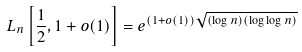Convert formula to latex. <formula><loc_0><loc_0><loc_500><loc_500>L _ { n } \left [ { \frac { 1 } { 2 } } , 1 + o ( 1 ) \right ] = e ^ { ( 1 + o ( 1 ) ) { \sqrt { ( \log n ) ( \log \log n ) } } }</formula> 